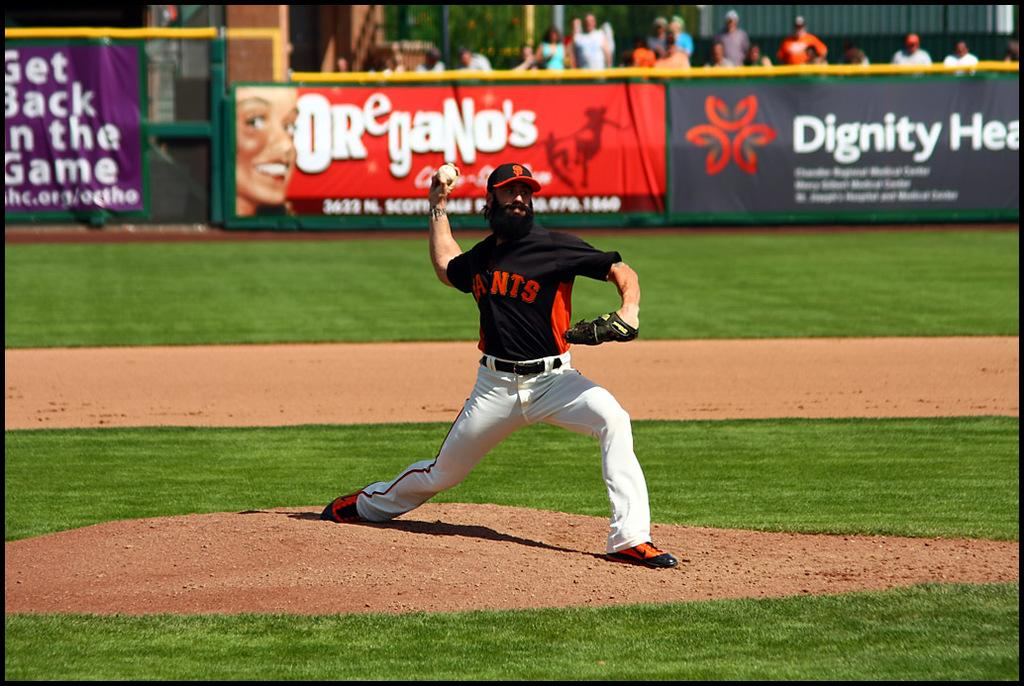Provide a one-sentence caption for the provided image. Man wearing a black jersey that says Ants pitching the ball. 